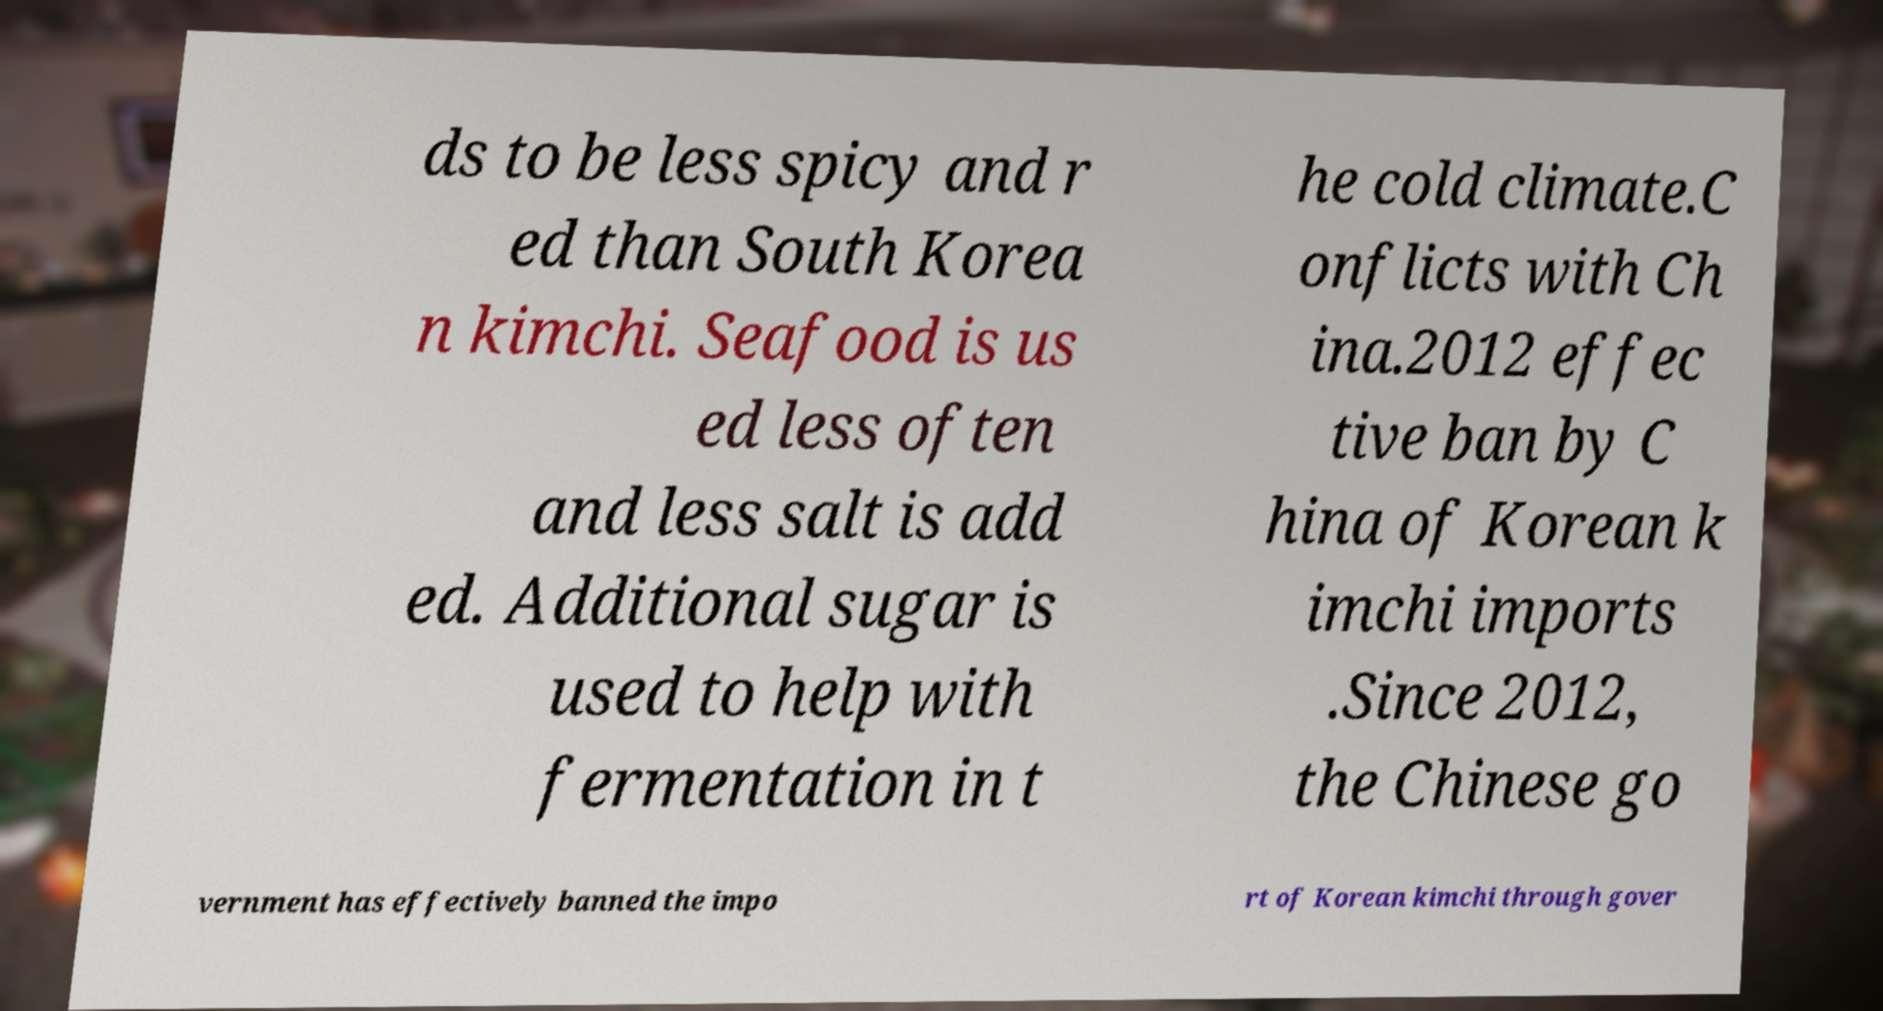I need the written content from this picture converted into text. Can you do that? ds to be less spicy and r ed than South Korea n kimchi. Seafood is us ed less often and less salt is add ed. Additional sugar is used to help with fermentation in t he cold climate.C onflicts with Ch ina.2012 effec tive ban by C hina of Korean k imchi imports .Since 2012, the Chinese go vernment has effectively banned the impo rt of Korean kimchi through gover 